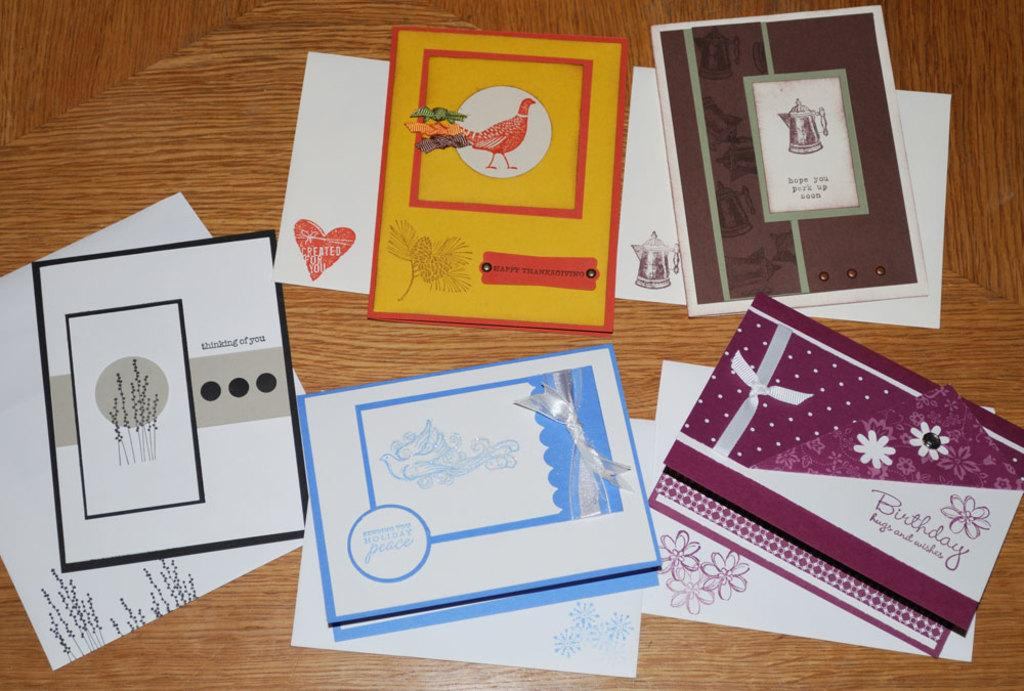Provide a one-sentence caption for the provided image. a card saying happy thanksgiving is mixed in with other cards. 